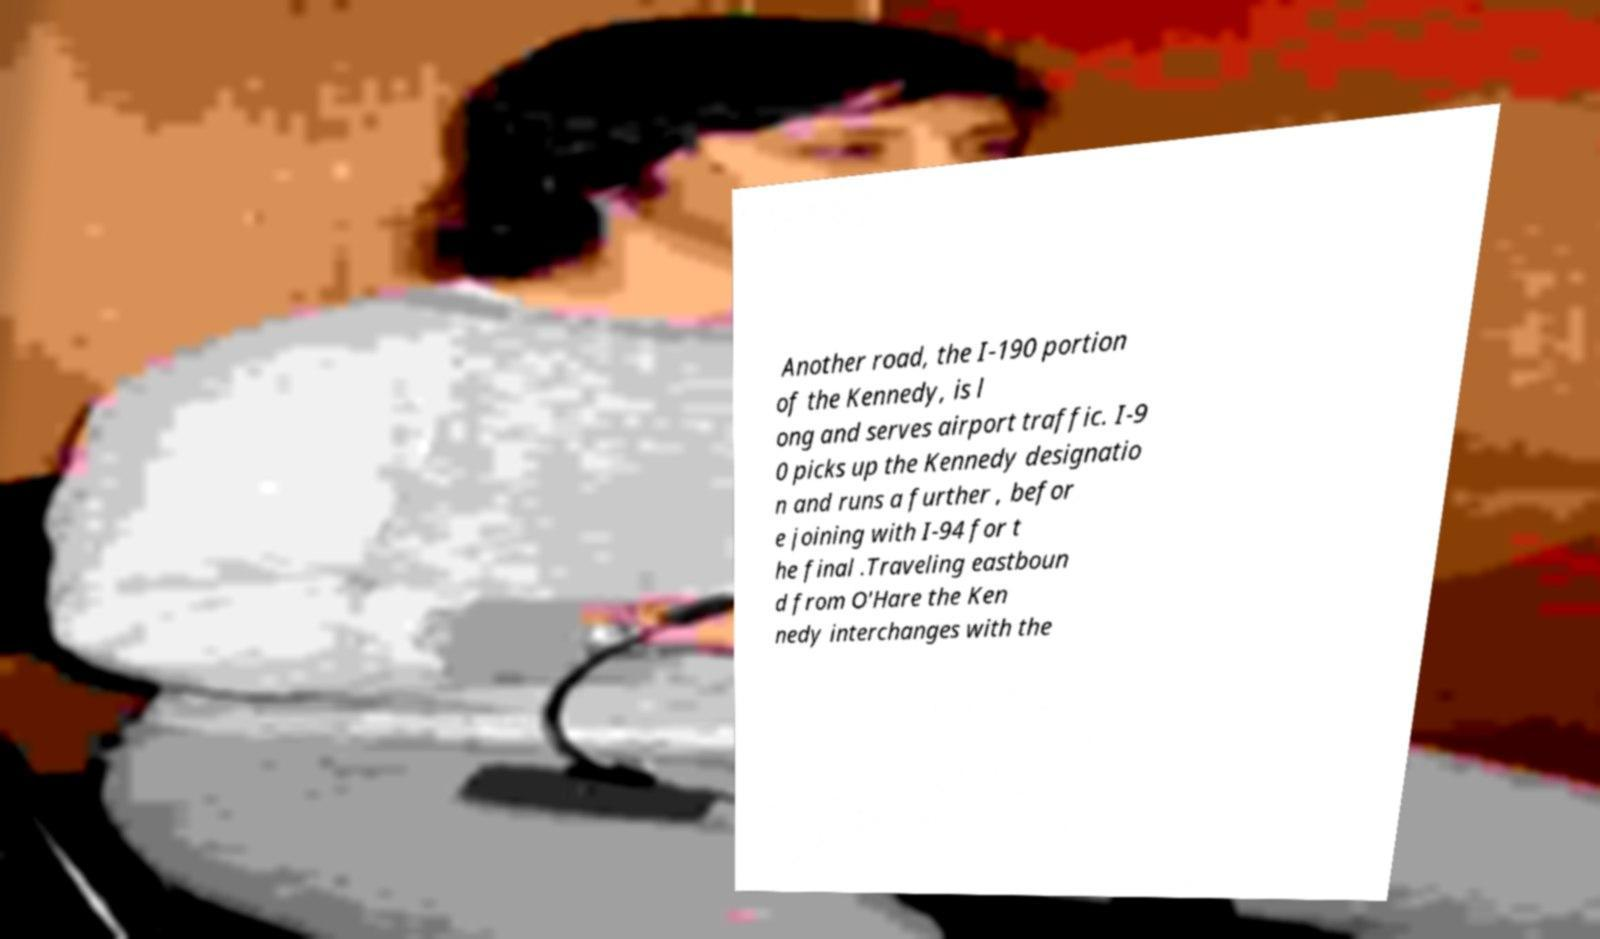What messages or text are displayed in this image? I need them in a readable, typed format. Another road, the I-190 portion of the Kennedy, is l ong and serves airport traffic. I-9 0 picks up the Kennedy designatio n and runs a further , befor e joining with I-94 for t he final .Traveling eastboun d from O'Hare the Ken nedy interchanges with the 